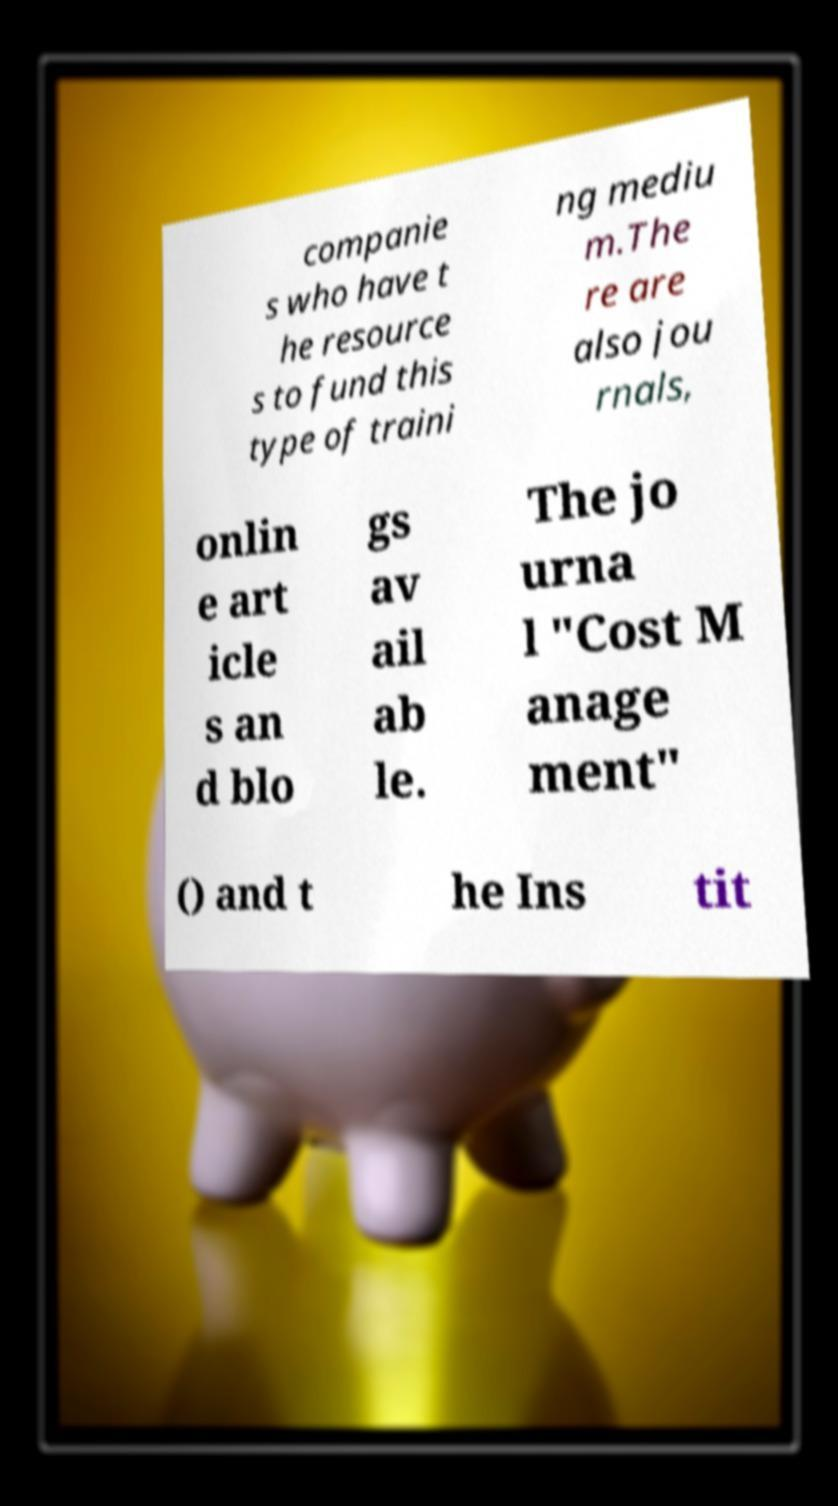Can you accurately transcribe the text from the provided image for me? companie s who have t he resource s to fund this type of traini ng mediu m.The re are also jou rnals, onlin e art icle s an d blo gs av ail ab le. The jo urna l "Cost M anage ment" () and t he Ins tit 